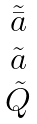<formula> <loc_0><loc_0><loc_500><loc_500>\begin{matrix} \tilde { \bar { a } } \\ \tilde { a } \\ \tilde { Q } \end{matrix}</formula> 